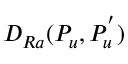<formula> <loc_0><loc_0><loc_500><loc_500>D _ { R a } ( P _ { u } , P _ { u } ^ { ^ { \prime } } )</formula> 